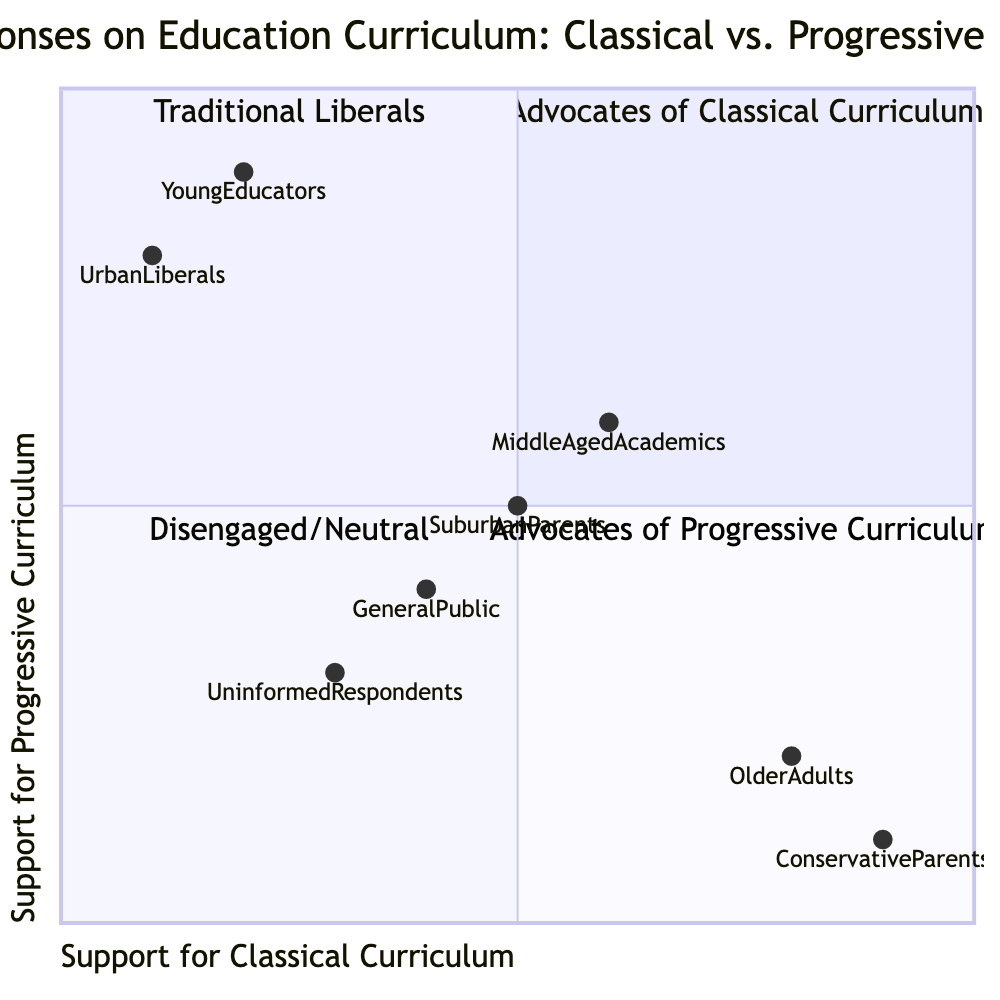What percentage of respondents support the classical curriculum? In the quadrant of Advocates of Classical Curriculum, the demographic 'Older Adults' is positioned at [0.8, 0.2], indicating 80% support for the classical approach. The demographic 'Conservative Parents' is at [0.9, 0.1], indicating 90% support for the classical approach. Therefore, both these groups together highlight a significant percentage in favor of a classical curriculum.
Answer: 80% Which demographic has the highest support for the progressive curriculum? The demographic 'Young Educators' is positioned at [0.2, 0.9], indicating 90% support for the progressive approach. 'Urban Liberals' is at [0.1, 0.8], indicating 80% support. Comparing these, 'Young Educators' has the highest support for progressive education.
Answer: Young Educators How many distinct groups advocate for classical curriculum? The quadrant chart shows two groups advocating for the classical curriculum: 'Older Adults' and 'Conservative Parents,' both in the Advocates of Classical Curriculum quadrant. Based on this observation, there are only two distinct groups that advocate for this curriculum.
Answer: 2 Which quadrant represents the respondents with a neutral opinion? The quadrant labeled "Disengaged/Neutral" represents respondents with little or no strong opinion on either classical or progressive education approaches. It categorizes those who do not have a specific preference for either curriculum.
Answer: Disengaged/Neutral What is the intersection point between traditional liberals and advocates of progressive curriculum? The Traditional Liberals quadrant represents respondents who balance elements of both classical and progressive methods but lean slightly towards progressive, while the Advocates of Progressive Curriculum quadrant clearly indicates a preference for modern educational methods. The intersection occurs where the two quadrants meet on the support scale.
Answer: Middle What unique demographic is found in the Disengaged/Neutral quadrant? The demographic 'General Public' within the Disengaged/Neutral quadrant is specified to have no strong opinion regarding either classical or progressive methods. This group signifies a broader spectrum of individuals without definitive educational stance.
Answer: General Public Which demographic represents both classical and progressive support equally? The demographic 'Middle-Aged Academics' is located at [0.6, 0.6], showing equal support for both classical and progressive curricula. This positioning reflects an ideal balance between traditional and modern educational preferences.
Answer: Middle-Aged Academics Which group shows the least support for the classical curriculum? The group 'Urban Liberals' is located at [0.1, 0.8], indicating only 10% support for the classical curriculum. This positioning demonstrates that this group favors progressive approaches significantly more than traditional ones.
Answer: Urban Liberals How does support for classical curriculum correlate with traditional liberal values? The quadrant for Traditional Liberals shows a balance between classical and progressive values with a slight inclination towards progressive approaches. The coordinates [0.6, 0.6] indicate equal support, demonstrating their hybrid perspective rather than a strict classical stance.
Answer: Balanced 